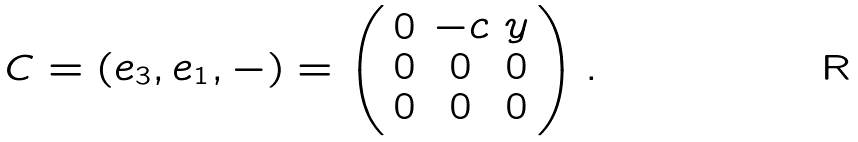Convert formula to latex. <formula><loc_0><loc_0><loc_500><loc_500>C = ( e _ { 3 } , e _ { 1 } , - ) = \left ( \begin{array} { c c c } 0 & - c & y \\ 0 & 0 & 0 \\ 0 & 0 & 0 \\ \end{array} \right ) .</formula> 